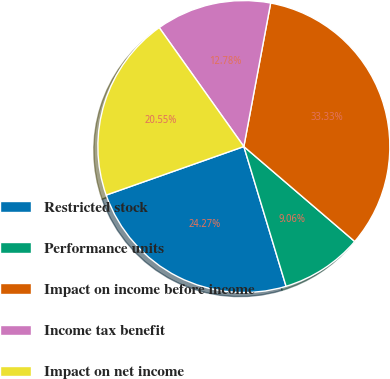Convert chart to OTSL. <chart><loc_0><loc_0><loc_500><loc_500><pie_chart><fcel>Restricted stock<fcel>Performance units<fcel>Impact on income before income<fcel>Income tax benefit<fcel>Impact on net income<nl><fcel>24.27%<fcel>9.06%<fcel>33.33%<fcel>12.78%<fcel>20.55%<nl></chart> 